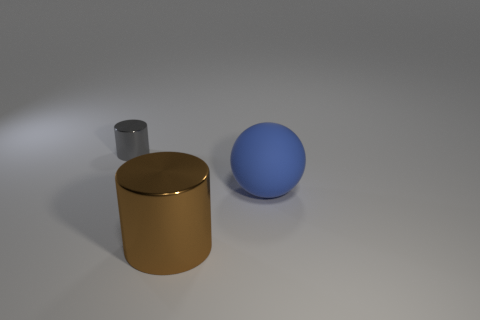Add 1 matte objects. How many objects exist? 4 Subtract all cylinders. How many objects are left? 1 Add 1 gray metallic objects. How many gray metallic objects exist? 2 Subtract 0 green spheres. How many objects are left? 3 Subtract all gray cylinders. Subtract all gray objects. How many objects are left? 1 Add 3 metal objects. How many metal objects are left? 5 